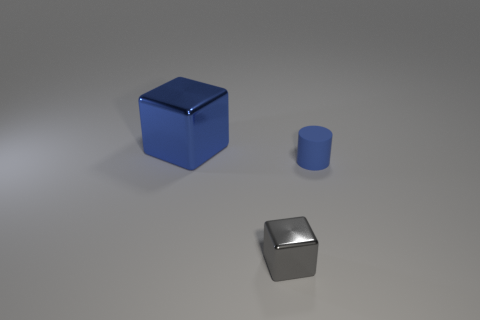What is the color of the metallic cube that is on the right side of the large blue thing? The metallic cube positioned to the right of the large blue cube is silver, showcasing a shiny surface which reflects light and accentuates its metallic properties. 